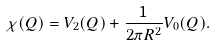Convert formula to latex. <formula><loc_0><loc_0><loc_500><loc_500>\chi ( Q ) = V _ { 2 } ( Q ) + \frac { 1 } { 2 \pi { R ^ { 2 } } } V _ { 0 } ( Q ) .</formula> 